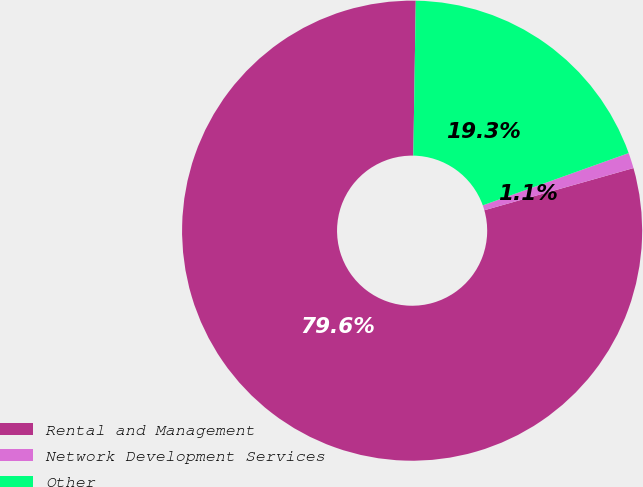Convert chart to OTSL. <chart><loc_0><loc_0><loc_500><loc_500><pie_chart><fcel>Rental and Management<fcel>Network Development Services<fcel>Other<nl><fcel>79.64%<fcel>1.09%<fcel>19.27%<nl></chart> 